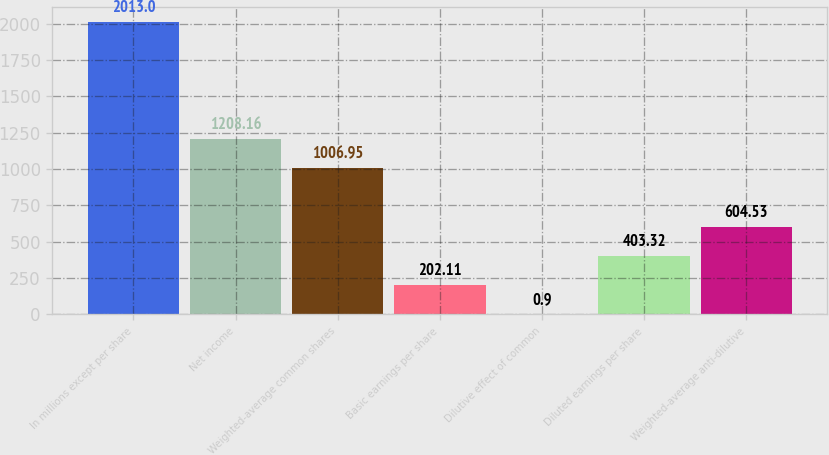Convert chart. <chart><loc_0><loc_0><loc_500><loc_500><bar_chart><fcel>In millions except per share<fcel>Net income<fcel>Weighted-average common shares<fcel>Basic earnings per share<fcel>Dilutive effect of common<fcel>Diluted earnings per share<fcel>Weighted-average anti-dilutive<nl><fcel>2013<fcel>1208.16<fcel>1006.95<fcel>202.11<fcel>0.9<fcel>403.32<fcel>604.53<nl></chart> 